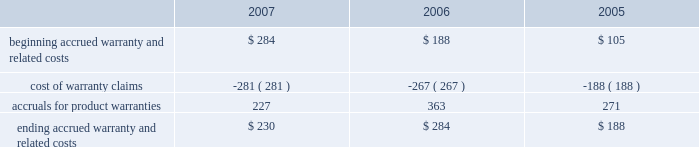Notes to consolidated financial statements ( continued ) note 8 2014commitments and contingencies ( continued ) the table reconciles changes in the company 2019s accrued warranties and related costs ( in millions ) : .
The company generally does not indemnify end-users of its operating system and application software against legal claims that the software infringes third-party intellectual property rights .
Other agreements entered into by the company sometimes include indemnification provisions under which the company could be subject to costs and/or damages in the event of an infringement claim against the company or an indemnified third-party .
However , the company has not been required to make any significant payments resulting from such an infringement claim asserted against itself or an indemnified third-party and , in the opinion of management , does not have a potential liability related to unresolved infringement claims subject to indemnification that would have a material adverse effect on its financial condition or operating results .
Therefore , the company did not record a liability for infringement costs as of either september 29 , 2007 or september 30 , 2006 .
Concentrations in the available sources of supply of materials and product certain key components including , but not limited to , microprocessors , enclosures , certain lcds , certain optical drives , and application-specific integrated circuits ( 2018 2018asics 2019 2019 ) are currently obtained by the company from single or limited sources which subjects the company to supply and pricing risks .
Many of these and other key components that are available from multiple sources including , but not limited to , nand flash memory , dram memory , and certain lcds , are at times subject to industry-wide shortages and significant commodity pricing fluctuations .
In addition , the company has entered into certain agreements for the supply of critical components at favorable pricing , and there is no guarantee that the company will be able to extend or renew these agreements when they expire .
Therefore , the company remains subject to significant risks of supply shortages and/or price increases that can adversely affect gross margins and operating margins .
In addition , the company uses some components that are not common to the rest of the global personal computer , consumer electronics and mobile communication industries , and new products introduced by the company often utilize custom components obtained from only one source until the company has evaluated whether there is a need for and subsequently qualifies additional suppliers .
If the supply of a key single-sourced component to the company were to be delayed or curtailed , or in the event a key manufacturing vendor delays shipments of completed products to the company , the company 2019s ability to ship related products in desired quantities and in a timely manner could be adversely affected .
The company 2019s business and financial performance could also be adversely affected depending on the time required to obtain sufficient quantities from the original source , or to identify and obtain sufficient quantities from an alternative source .
Continued availability of these components may be affected if producers were to decide to concentrate on the production of common components instead of components customized to meet the company 2019s requirements .
Finally , significant portions of the company 2019s cpus , ipods , iphones , logic boards , and other assembled products are now manufactured by outsourcing partners , primarily in various parts of asia .
A significant concentration of this outsourced manufacturing is currently performed by only a few of the company 2019s outsourcing partners , often in single locations .
Certain of these outsourcing partners are the sole-sourced supplier of components and manufacturing outsourcing for many of the company 2019s key products , including but not limited to , assembly .
What was the change in ending accrued warranty and related cost between 2006 and 2007 , in millions? 
Computations: (230 - 284)
Answer: -54.0. 